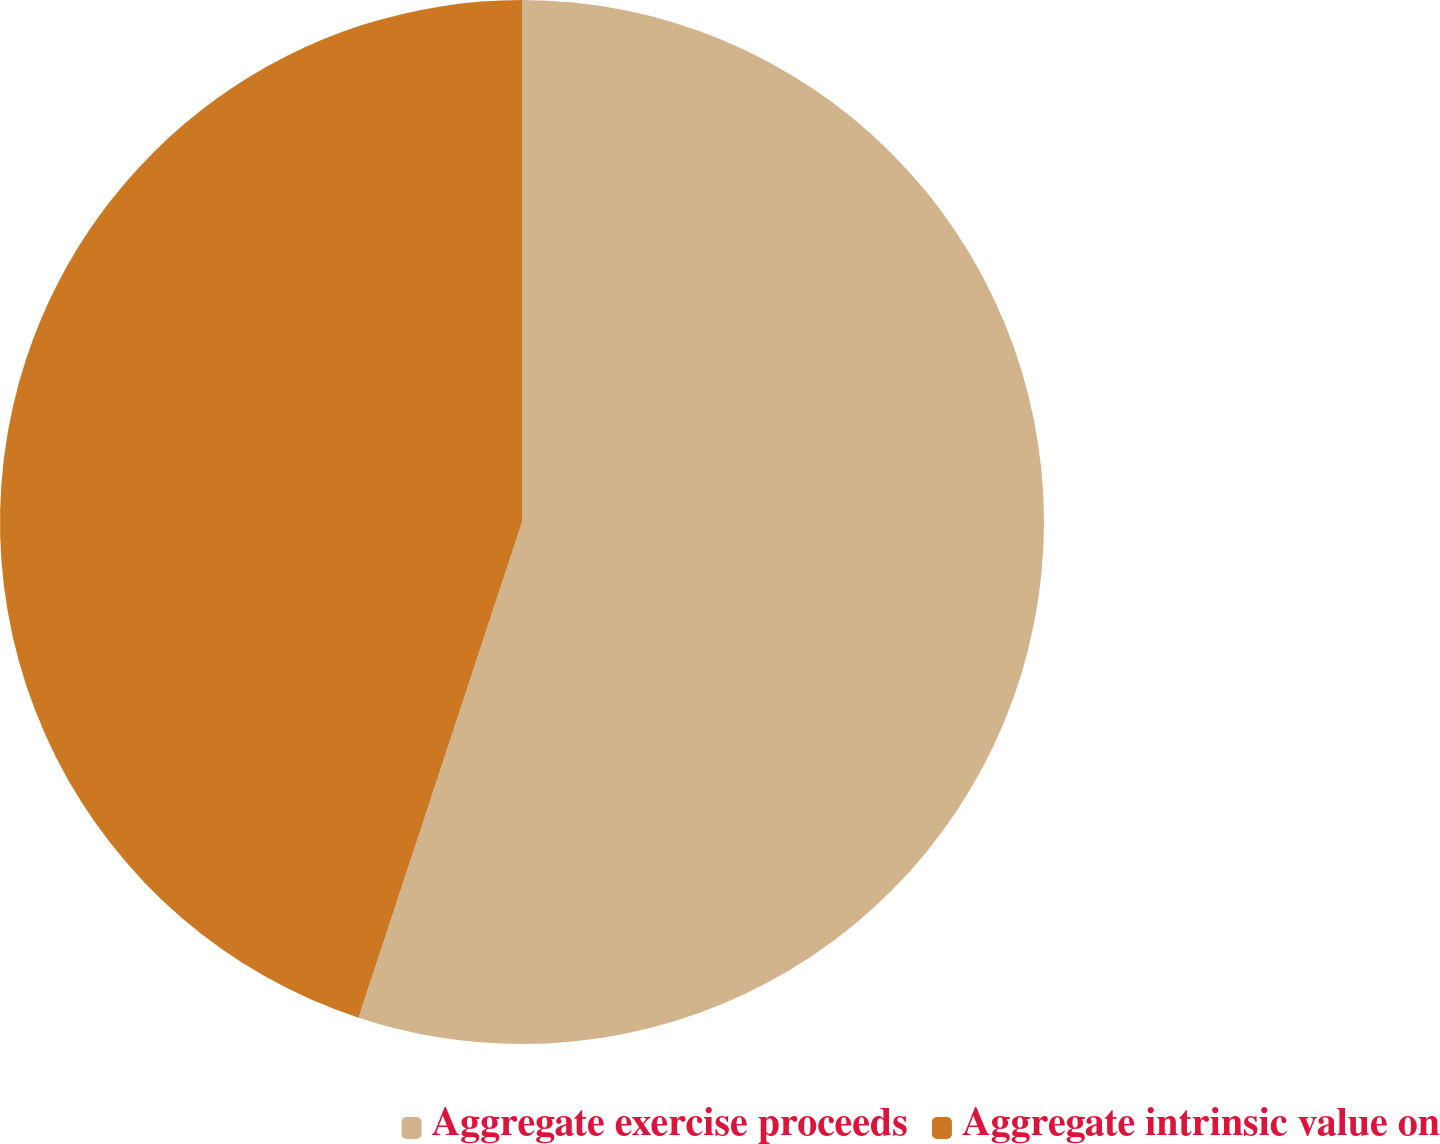Convert chart. <chart><loc_0><loc_0><loc_500><loc_500><pie_chart><fcel>Aggregate exercise proceeds<fcel>Aggregate intrinsic value on<nl><fcel>55.07%<fcel>44.93%<nl></chart> 